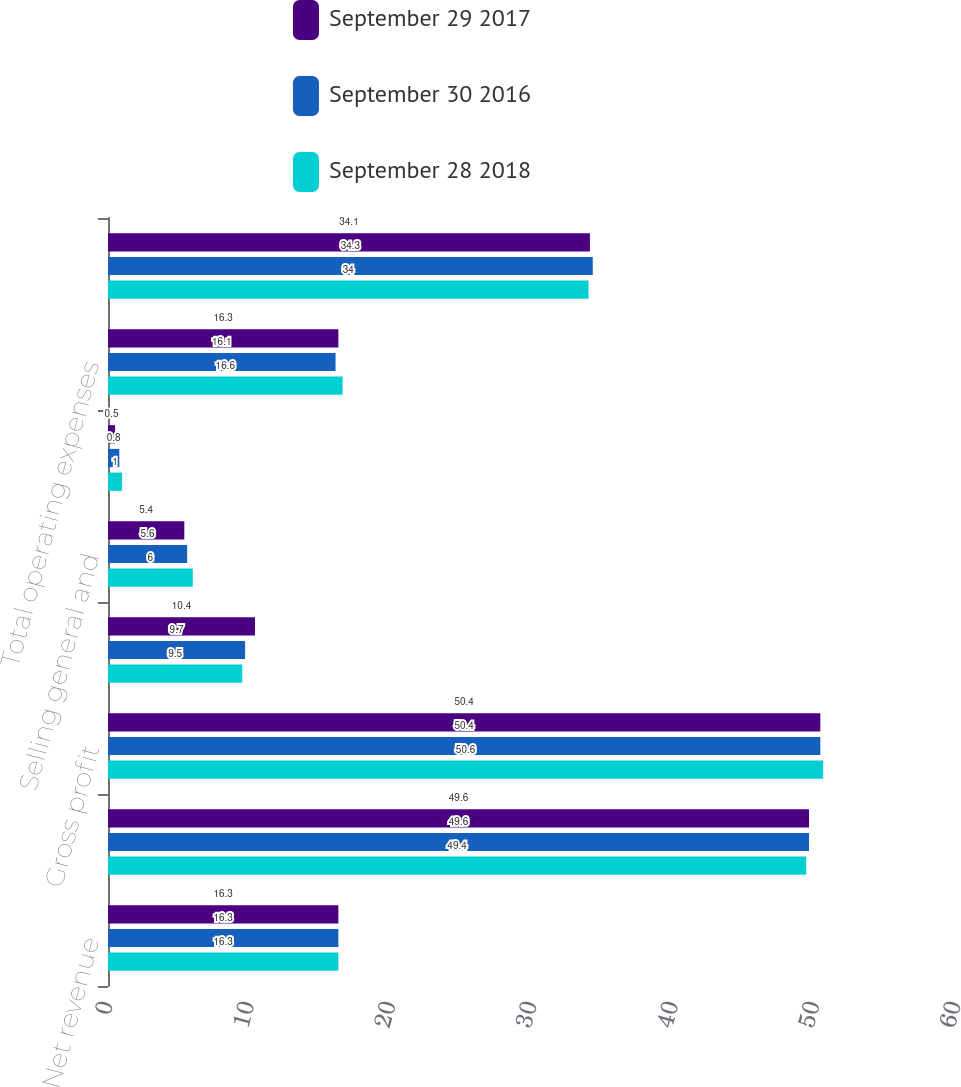Convert chart. <chart><loc_0><loc_0><loc_500><loc_500><stacked_bar_chart><ecel><fcel>Net revenue<fcel>Cost of goods sold<fcel>Gross profit<fcel>Research and development<fcel>Selling general and<fcel>Amortization of intangibles<fcel>Total operating expenses<fcel>Operating income<nl><fcel>September 29 2017<fcel>16.3<fcel>49.6<fcel>50.4<fcel>10.4<fcel>5.4<fcel>0.5<fcel>16.3<fcel>34.1<nl><fcel>September 30 2016<fcel>16.3<fcel>49.6<fcel>50.4<fcel>9.7<fcel>5.6<fcel>0.8<fcel>16.1<fcel>34.3<nl><fcel>September 28 2018<fcel>16.3<fcel>49.4<fcel>50.6<fcel>9.5<fcel>6<fcel>1<fcel>16.6<fcel>34<nl></chart> 